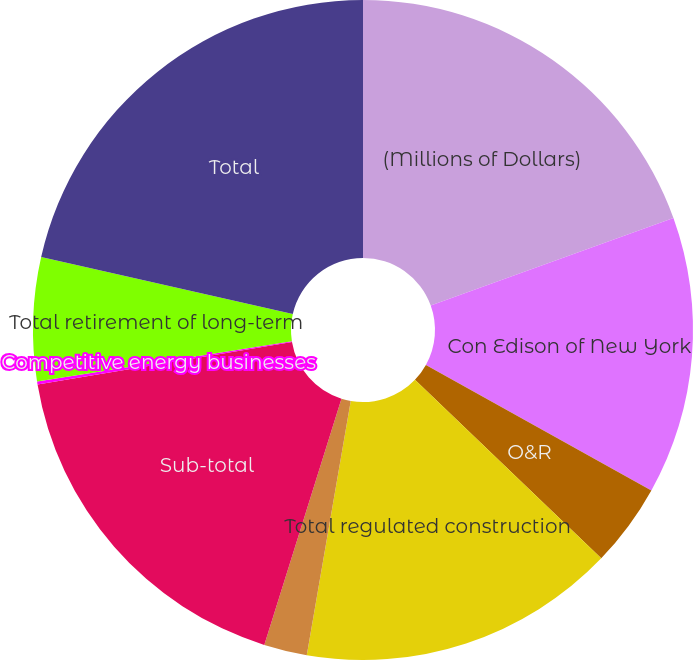Convert chart to OTSL. <chart><loc_0><loc_0><loc_500><loc_500><pie_chart><fcel>(Millions of Dollars)<fcel>Con Edison of New York<fcel>O&R<fcel>Total regulated construction<fcel>Competitive businesses<fcel>Sub-total<fcel>Competitive energy businesses<fcel>Total retirement of long-term<fcel>Total<nl><fcel>19.49%<fcel>13.59%<fcel>4.08%<fcel>15.56%<fcel>2.11%<fcel>17.52%<fcel>0.15%<fcel>6.04%<fcel>21.45%<nl></chart> 